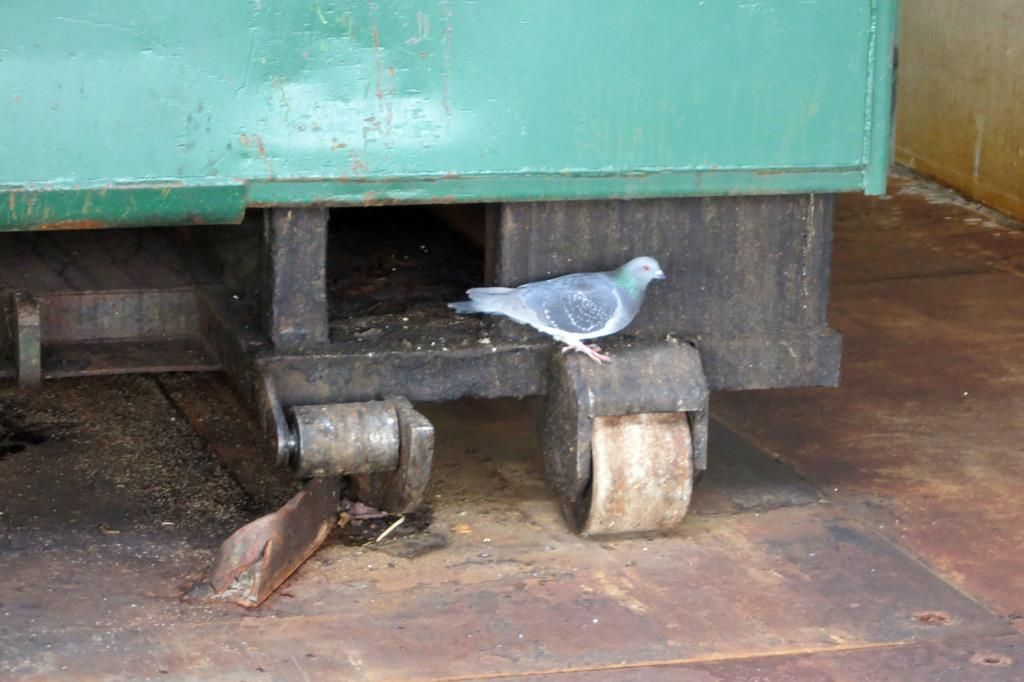What animal can be seen on a wheel in the image? There is a bird visible on a wheel in the image. What color is the fence at the top of the image? The fence at the top of the image is green. What structure is located on the right side of the image? There is a wall on the right side of the image. What type of copper material is used to make the bird's beak in the image? There is no mention of copper or any specific material for the bird's beak in the image. The bird's beak is not described in the provided facts. 